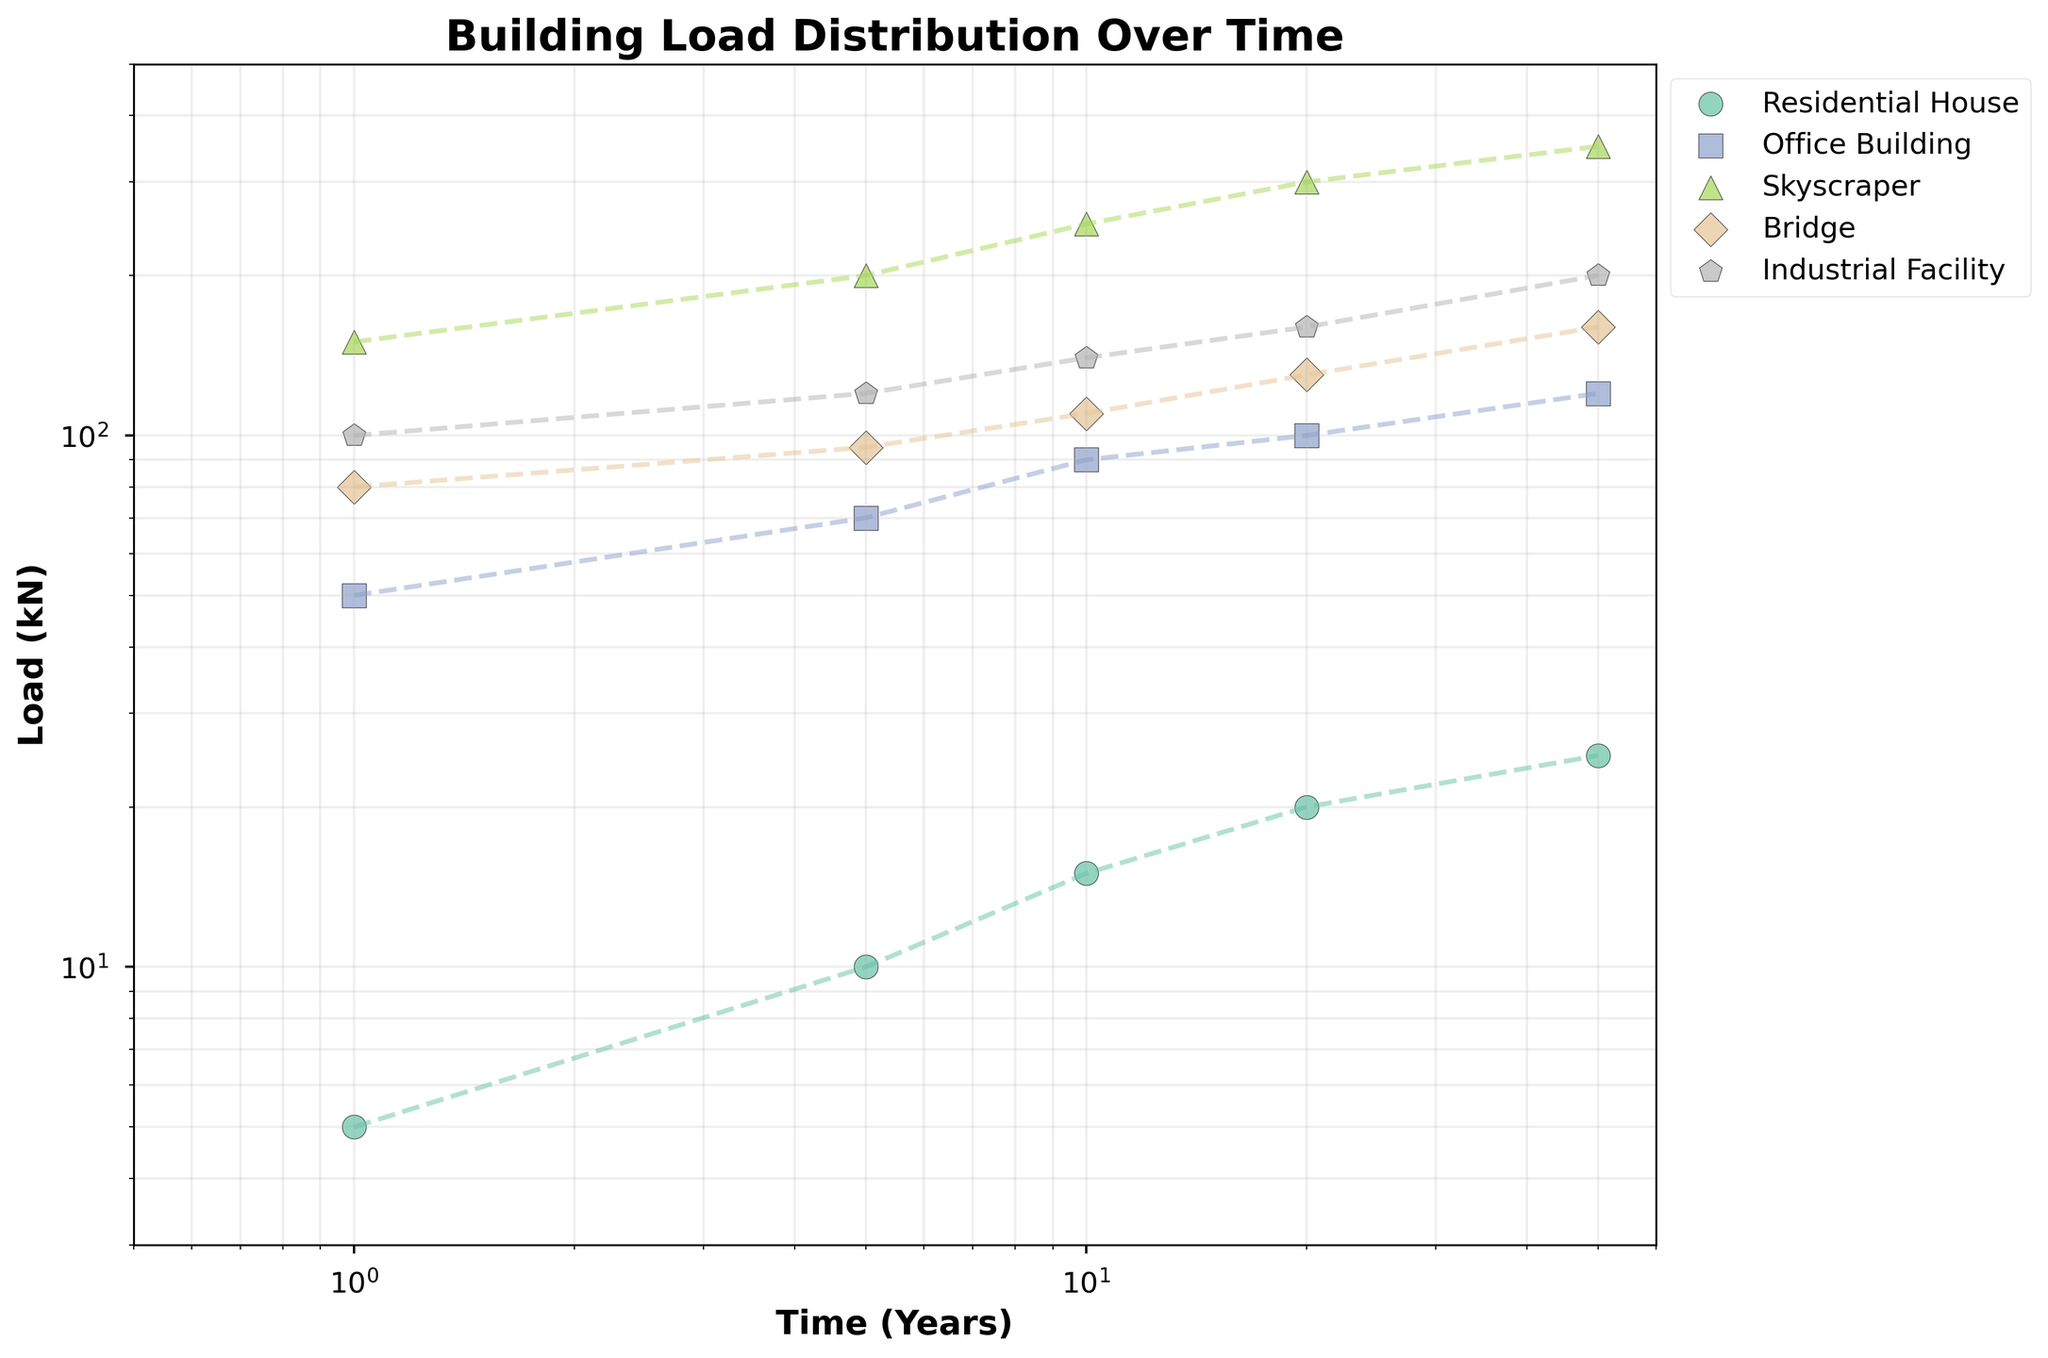How many types of structures are represented in the plot? Identify the number of unique labels in the legend, which means distinct types of structures.
Answer: 5 types What kind of scale is used for the x-axis and y-axis? Observe the labels on both axes; they follow a non-linear progression and include 'log' in the axis settings.
Answer: Logarithmic What is the title of the plot? It's usually found at the top, centered above the figure.
Answer: Building Load Distribution Over Time Which structure has the highest initial load at Year 1? Look at the starting point for each structure. Compare their load values at Time = 1.
Answer: Skyscraper Which structure shows the least amount of change in load over 50 years? Compare the load increase across structures from Year 1 to Year 50, and identify the one with the smallest load change.
Answer: Residential House What is the load value for the Bridge at 10 years? Locate the Bridge data points and find the one corresponding to Time = 10.
Answer: 110 kN Compare the load increase for the Office Building and the Industrial Facility from Year 1 to Year 50. Which one increased more? Calculate the difference between the Year 1 and Year 50 loads for both structures. Compare the differences.
Answer: Office Building At 20 years, which structure has a load closest to 150 kN? Check the load values at Time = 20 for all structures and find the one near 150 kN.
Answer: Skyscraper Between the Residential House and Bridge, which one has a greater load at 5 years? Compare the load values for both structures at Time = 5.
Answer: Bridge What trend do you observe for the load values over time across all structures? Look at the plotted lines for all structures to identify a general pattern or trend in load values.
Answer: Increasing trend 